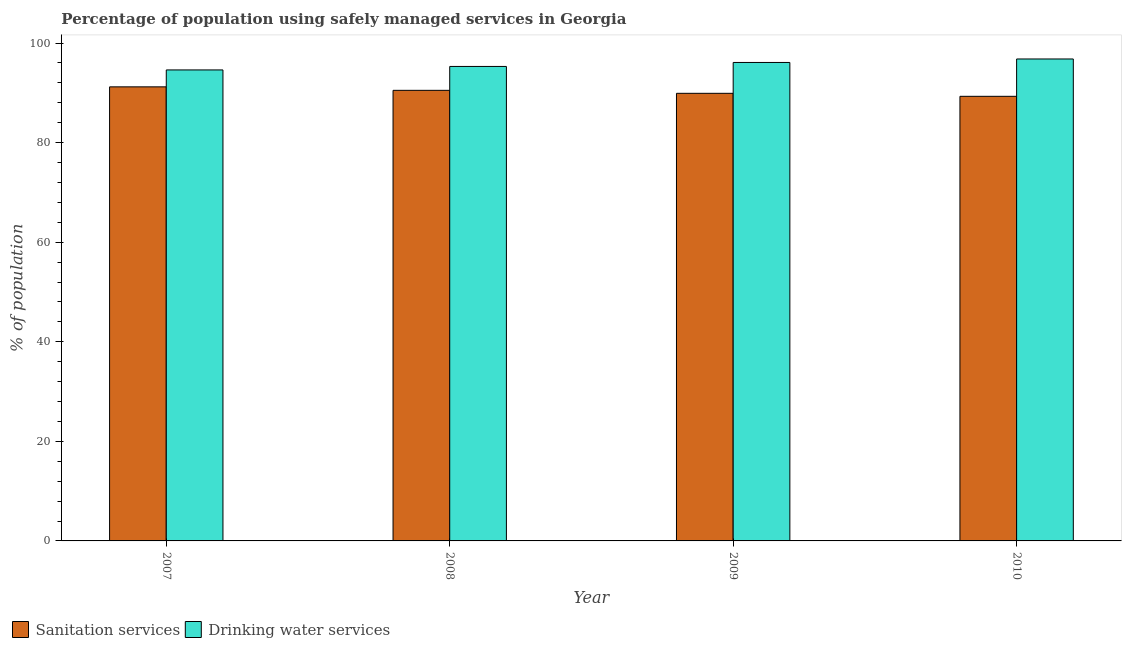How many different coloured bars are there?
Provide a succinct answer. 2. How many groups of bars are there?
Your response must be concise. 4. Are the number of bars per tick equal to the number of legend labels?
Ensure brevity in your answer.  Yes. Are the number of bars on each tick of the X-axis equal?
Keep it short and to the point. Yes. How many bars are there on the 1st tick from the left?
Ensure brevity in your answer.  2. How many bars are there on the 4th tick from the right?
Your answer should be very brief. 2. In how many cases, is the number of bars for a given year not equal to the number of legend labels?
Offer a terse response. 0. What is the percentage of population who used drinking water services in 2009?
Your answer should be compact. 96.1. Across all years, what is the maximum percentage of population who used sanitation services?
Make the answer very short. 91.2. Across all years, what is the minimum percentage of population who used drinking water services?
Your answer should be compact. 94.6. What is the total percentage of population who used drinking water services in the graph?
Your answer should be compact. 382.8. What is the difference between the percentage of population who used drinking water services in 2009 and that in 2010?
Make the answer very short. -0.7. What is the difference between the percentage of population who used sanitation services in 2009 and the percentage of population who used drinking water services in 2007?
Provide a short and direct response. -1.3. What is the average percentage of population who used drinking water services per year?
Make the answer very short. 95.7. In how many years, is the percentage of population who used drinking water services greater than 52 %?
Offer a terse response. 4. What is the ratio of the percentage of population who used drinking water services in 2009 to that in 2010?
Your response must be concise. 0.99. Is the percentage of population who used drinking water services in 2008 less than that in 2009?
Provide a succinct answer. Yes. What is the difference between the highest and the second highest percentage of population who used drinking water services?
Make the answer very short. 0.7. What is the difference between the highest and the lowest percentage of population who used drinking water services?
Your answer should be very brief. 2.2. What does the 2nd bar from the left in 2007 represents?
Offer a very short reply. Drinking water services. What does the 1st bar from the right in 2009 represents?
Your answer should be compact. Drinking water services. How many bars are there?
Give a very brief answer. 8. Are the values on the major ticks of Y-axis written in scientific E-notation?
Your answer should be compact. No. Does the graph contain grids?
Ensure brevity in your answer.  No. Where does the legend appear in the graph?
Keep it short and to the point. Bottom left. What is the title of the graph?
Give a very brief answer. Percentage of population using safely managed services in Georgia. Does "Manufacturing industries and construction" appear as one of the legend labels in the graph?
Provide a succinct answer. No. What is the label or title of the X-axis?
Offer a terse response. Year. What is the label or title of the Y-axis?
Give a very brief answer. % of population. What is the % of population of Sanitation services in 2007?
Provide a short and direct response. 91.2. What is the % of population of Drinking water services in 2007?
Offer a terse response. 94.6. What is the % of population in Sanitation services in 2008?
Your answer should be compact. 90.5. What is the % of population in Drinking water services in 2008?
Keep it short and to the point. 95.3. What is the % of population of Sanitation services in 2009?
Ensure brevity in your answer.  89.9. What is the % of population in Drinking water services in 2009?
Make the answer very short. 96.1. What is the % of population of Sanitation services in 2010?
Your response must be concise. 89.3. What is the % of population of Drinking water services in 2010?
Make the answer very short. 96.8. Across all years, what is the maximum % of population in Sanitation services?
Make the answer very short. 91.2. Across all years, what is the maximum % of population of Drinking water services?
Your response must be concise. 96.8. Across all years, what is the minimum % of population of Sanitation services?
Your response must be concise. 89.3. Across all years, what is the minimum % of population in Drinking water services?
Offer a terse response. 94.6. What is the total % of population of Sanitation services in the graph?
Give a very brief answer. 360.9. What is the total % of population in Drinking water services in the graph?
Your answer should be very brief. 382.8. What is the difference between the % of population in Sanitation services in 2007 and that in 2008?
Provide a succinct answer. 0.7. What is the difference between the % of population of Drinking water services in 2007 and that in 2008?
Give a very brief answer. -0.7. What is the difference between the % of population in Drinking water services in 2007 and that in 2009?
Provide a succinct answer. -1.5. What is the difference between the % of population of Drinking water services in 2007 and that in 2010?
Offer a very short reply. -2.2. What is the difference between the % of population in Drinking water services in 2008 and that in 2009?
Offer a very short reply. -0.8. What is the difference between the % of population in Sanitation services in 2008 and that in 2010?
Keep it short and to the point. 1.2. What is the difference between the % of population in Drinking water services in 2008 and that in 2010?
Offer a terse response. -1.5. What is the difference between the % of population in Sanitation services in 2009 and that in 2010?
Your answer should be compact. 0.6. What is the difference between the % of population of Drinking water services in 2009 and that in 2010?
Your answer should be compact. -0.7. What is the difference between the % of population in Sanitation services in 2007 and the % of population in Drinking water services in 2008?
Give a very brief answer. -4.1. What is the difference between the % of population in Sanitation services in 2007 and the % of population in Drinking water services in 2009?
Make the answer very short. -4.9. What is the difference between the % of population of Sanitation services in 2008 and the % of population of Drinking water services in 2009?
Give a very brief answer. -5.6. What is the difference between the % of population of Sanitation services in 2008 and the % of population of Drinking water services in 2010?
Your answer should be compact. -6.3. What is the average % of population of Sanitation services per year?
Offer a very short reply. 90.22. What is the average % of population of Drinking water services per year?
Keep it short and to the point. 95.7. In the year 2008, what is the difference between the % of population of Sanitation services and % of population of Drinking water services?
Provide a succinct answer. -4.8. What is the ratio of the % of population in Sanitation services in 2007 to that in 2008?
Your answer should be very brief. 1.01. What is the ratio of the % of population in Drinking water services in 2007 to that in 2008?
Provide a short and direct response. 0.99. What is the ratio of the % of population of Sanitation services in 2007 to that in 2009?
Your answer should be compact. 1.01. What is the ratio of the % of population of Drinking water services in 2007 to that in 2009?
Your answer should be compact. 0.98. What is the ratio of the % of population in Sanitation services in 2007 to that in 2010?
Offer a terse response. 1.02. What is the ratio of the % of population of Drinking water services in 2007 to that in 2010?
Keep it short and to the point. 0.98. What is the ratio of the % of population of Drinking water services in 2008 to that in 2009?
Your response must be concise. 0.99. What is the ratio of the % of population in Sanitation services in 2008 to that in 2010?
Give a very brief answer. 1.01. What is the ratio of the % of population in Drinking water services in 2008 to that in 2010?
Give a very brief answer. 0.98. What is the ratio of the % of population in Sanitation services in 2009 to that in 2010?
Keep it short and to the point. 1.01. What is the difference between the highest and the second highest % of population of Sanitation services?
Offer a terse response. 0.7. What is the difference between the highest and the second highest % of population in Drinking water services?
Provide a succinct answer. 0.7. What is the difference between the highest and the lowest % of population of Sanitation services?
Provide a succinct answer. 1.9. 